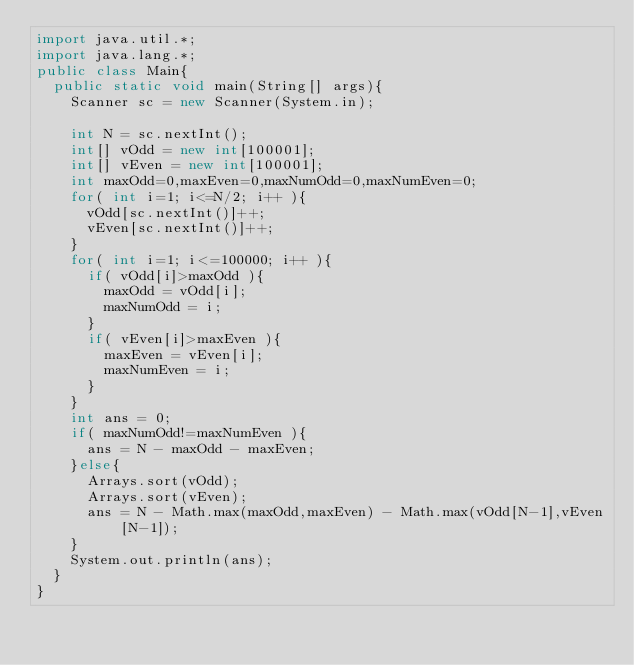<code> <loc_0><loc_0><loc_500><loc_500><_Java_>import java.util.*;
import java.lang.*;
public class Main{
	public static void main(String[] args){
		Scanner sc = new Scanner(System.in);
		
		int N = sc.nextInt();
		int[] vOdd = new int[100001];
		int[] vEven = new int[100001];
		int maxOdd=0,maxEven=0,maxNumOdd=0,maxNumEven=0;
		for( int i=1; i<=N/2; i++ ){
			vOdd[sc.nextInt()]++;
			vEven[sc.nextInt()]++;
		}
		for( int i=1; i<=100000; i++ ){
			if( vOdd[i]>maxOdd ){
				maxOdd = vOdd[i];
				maxNumOdd = i;
			}
			if( vEven[i]>maxEven ){
				maxEven = vEven[i];
				maxNumEven = i;
			}
		}
		int ans = 0;      
		if( maxNumOdd!=maxNumEven ){
			ans = N - maxOdd - maxEven;
		}else{
			Arrays.sort(vOdd);
			Arrays.sort(vEven);
			ans = N - Math.max(maxOdd,maxEven) - Math.max(vOdd[N-1],vEven[N-1]);
		}
		System.out.println(ans);
	}
}
</code> 